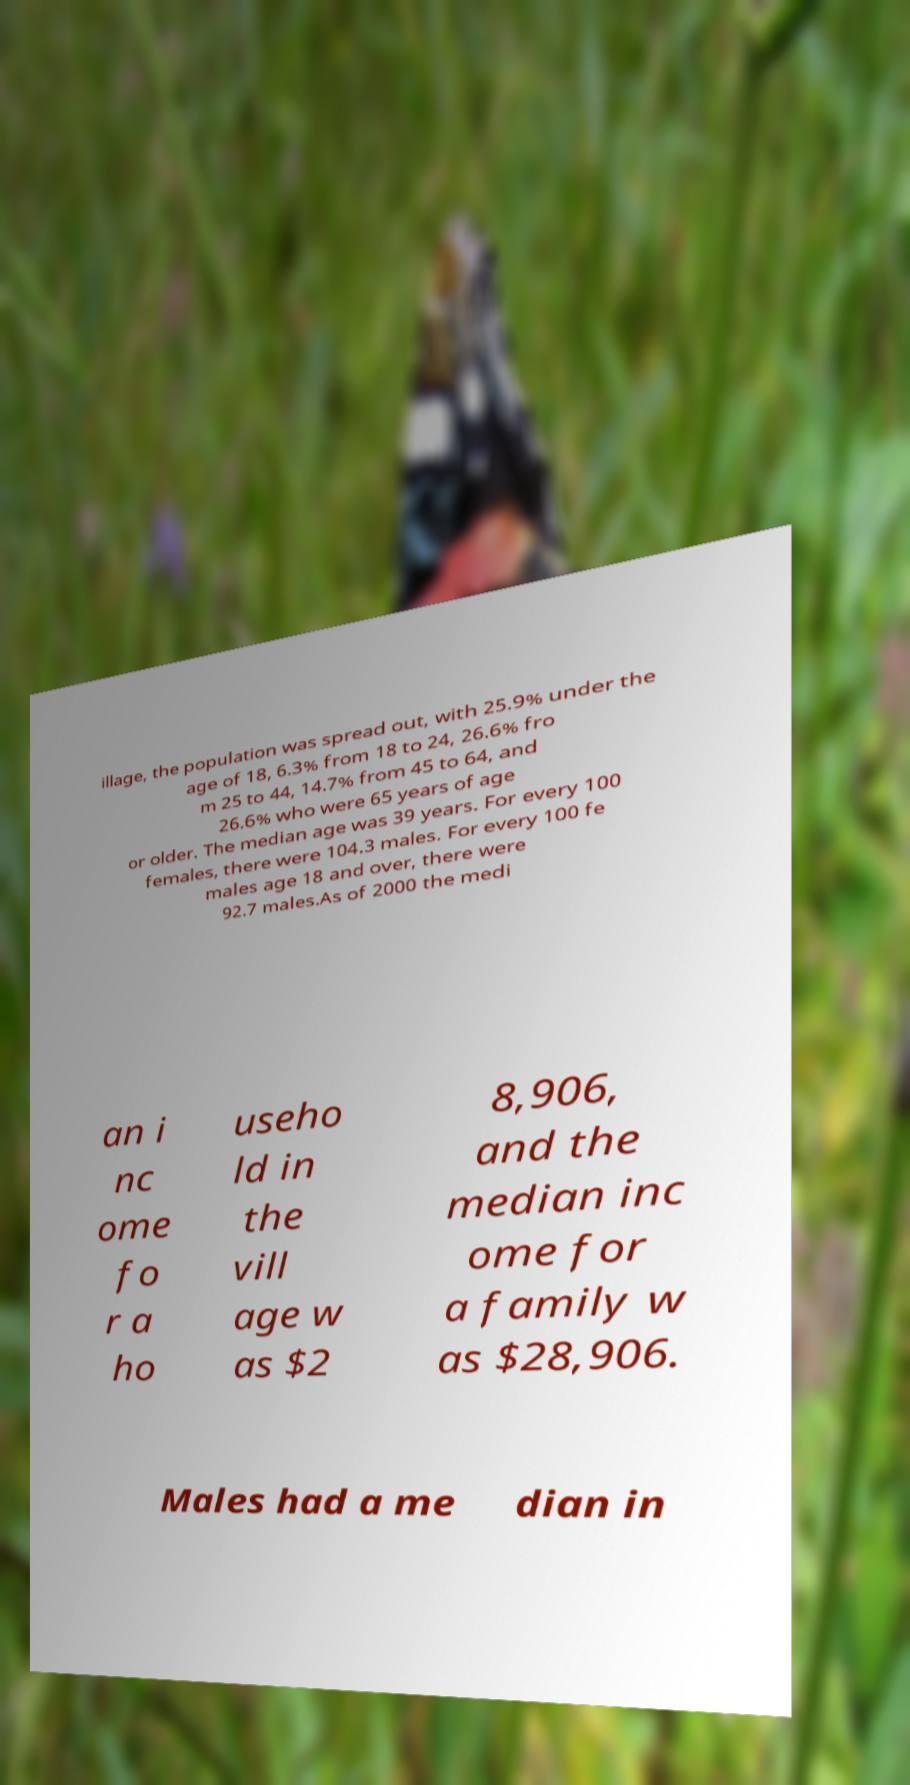Could you assist in decoding the text presented in this image and type it out clearly? illage, the population was spread out, with 25.9% under the age of 18, 6.3% from 18 to 24, 26.6% fro m 25 to 44, 14.7% from 45 to 64, and 26.6% who were 65 years of age or older. The median age was 39 years. For every 100 females, there were 104.3 males. For every 100 fe males age 18 and over, there were 92.7 males.As of 2000 the medi an i nc ome fo r a ho useho ld in the vill age w as $2 8,906, and the median inc ome for a family w as $28,906. Males had a me dian in 